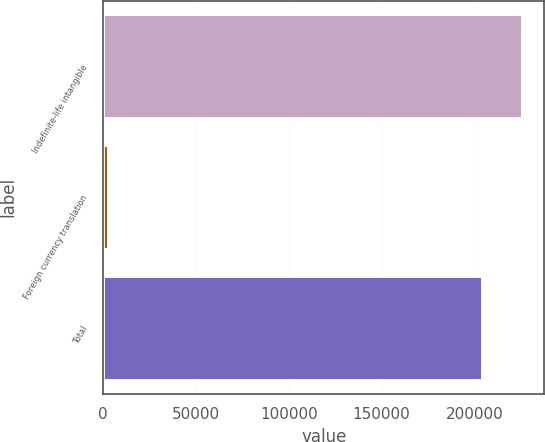Convert chart. <chart><loc_0><loc_0><loc_500><loc_500><bar_chart><fcel>Indefinite-life intangible<fcel>Foreign currency translation<fcel>Total<nl><fcel>226420<fcel>3339<fcel>204866<nl></chart> 